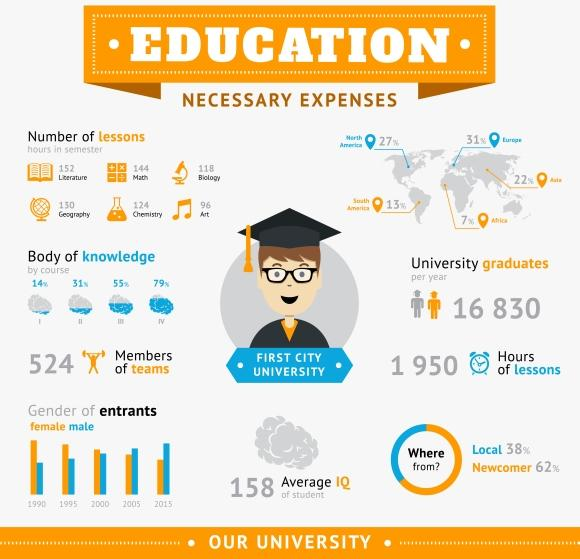Draw attention to some important aspects in this diagram. 1995 had the second-lowest number of male entrants out of all the years listed. In 2000, there were fewer females participating in a particular event than in any other year. The first city university offers a total of six topics as course streams. 